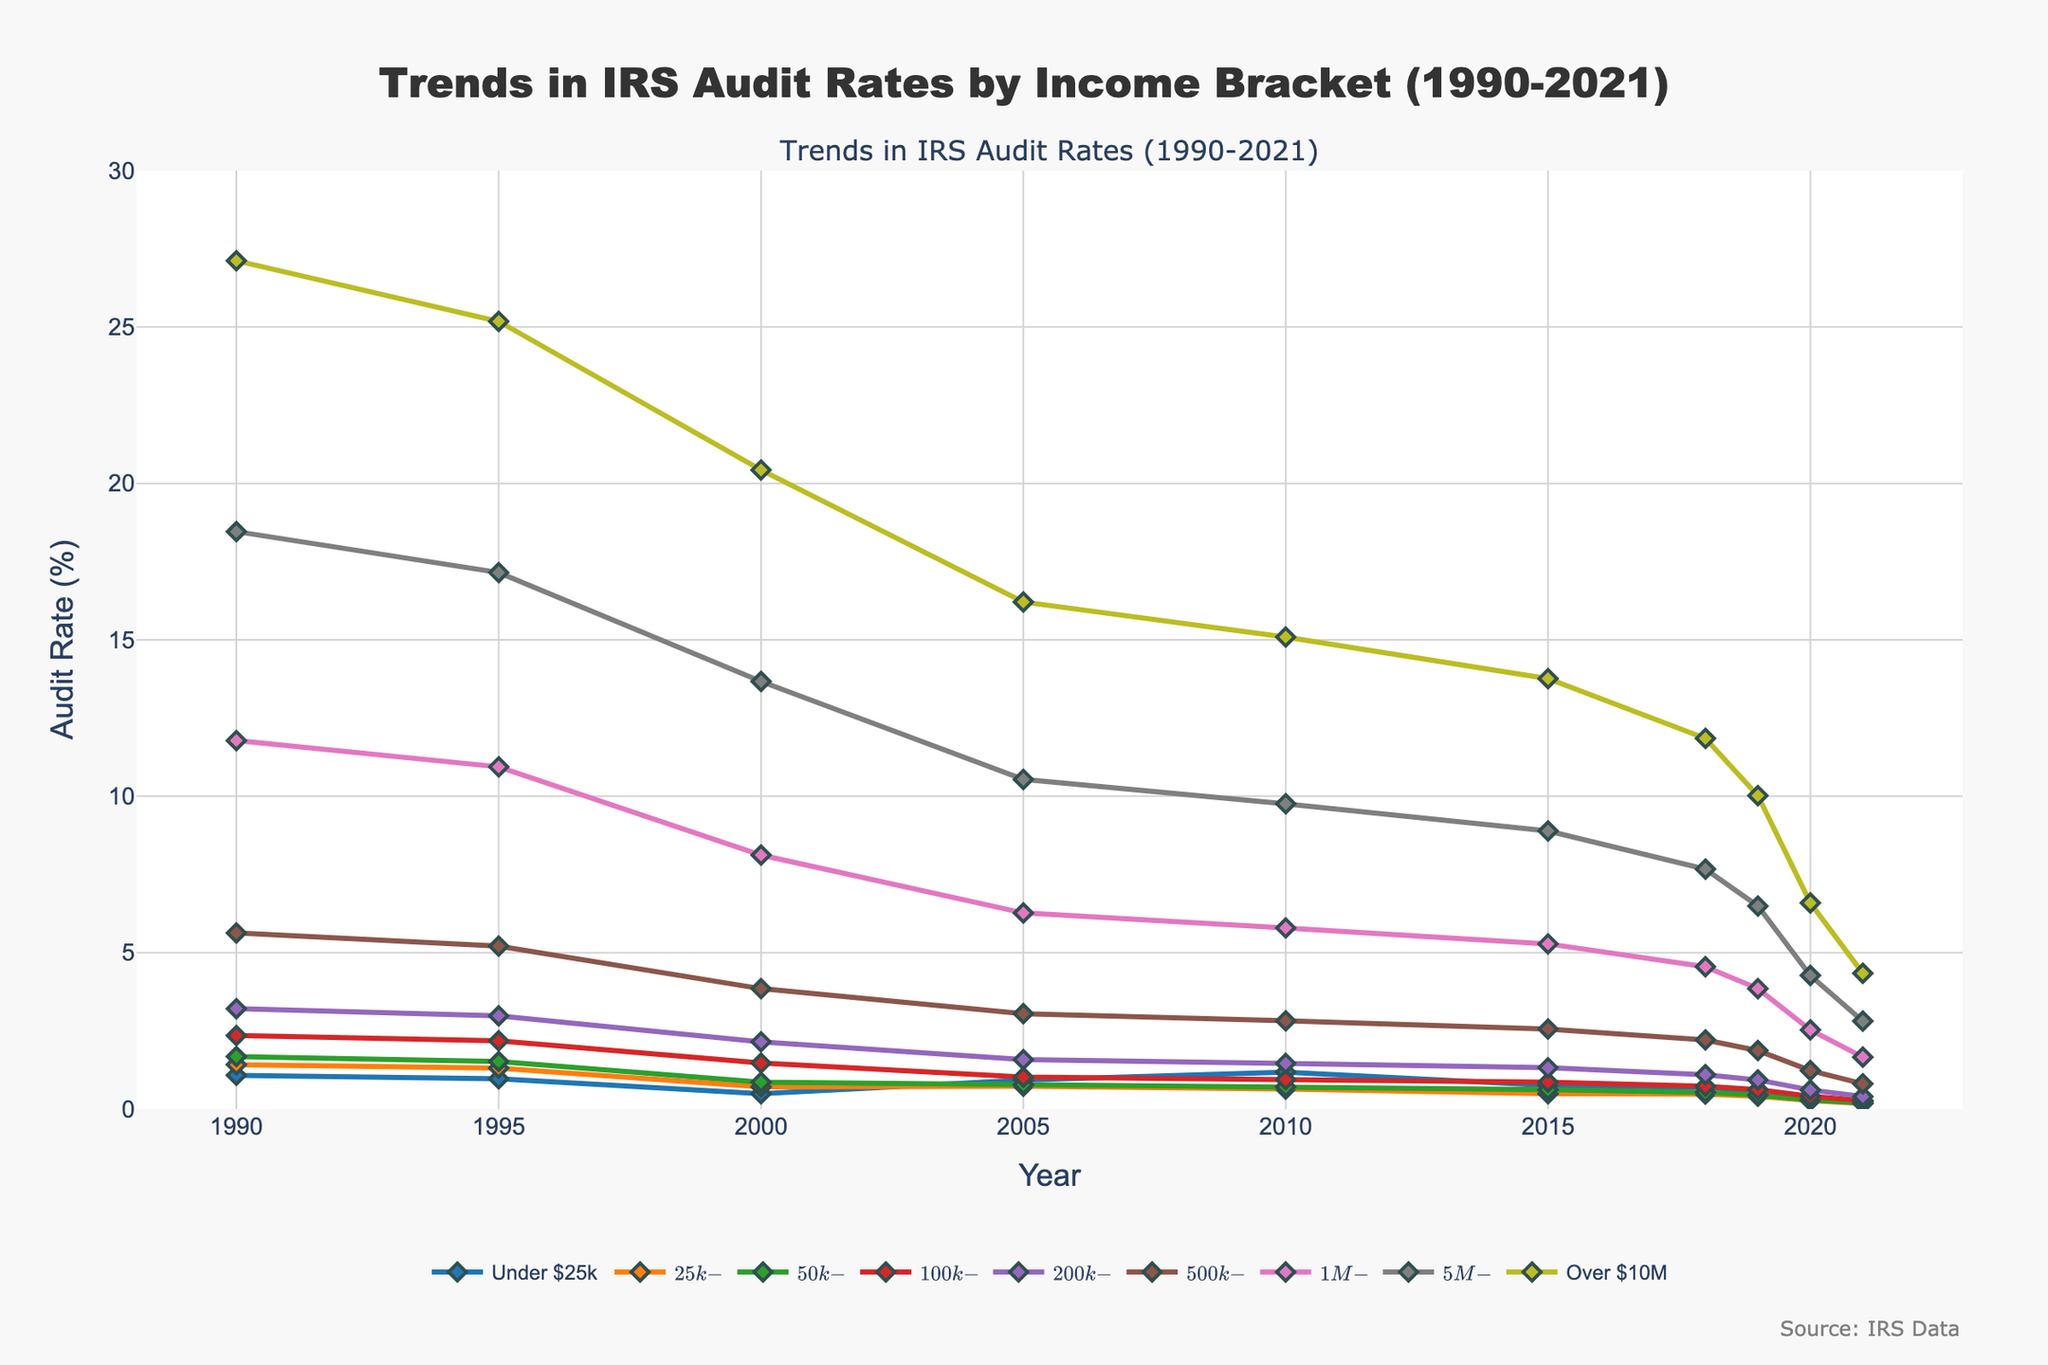What trend can you observe for audit rates for the income bracket "$25k-$50k" from 1990 to 2021? The audit rates for the $25k-$50k income bracket consistently decline from 1990 (1.42%) to 2021 (0.18%), indicating fewer audits over time.
Answer: Consistent decline Which income bracket had the highest audit rate in 2021? Observing the end of each line in 2021, the income bracket "Over $10M" had the highest audit rate in 2021.
Answer: Over $10M Compare the audit rates for the income brackets "Under $25k" and "$200k-$500k" in 2000. Which one was higher and by how much? In 2000, the audit rate for "Under $25k" was 0.49% and for "$200k-$500k" was 2.15%. The rate for "$200k-$500k" was higher by 2.15 - 0.49 = 1.66%.
Answer: $200k-$500k by 1.66% Identify the income bracket with the largest decrease in audit rate from 1995 to 2021. What is the difference in percentages? By comparing each bracket, "$5M-$10M" had the largest decrease from 17.15% in 1995 to 2.81% in 2021, which is a decrease of 17.15 - 2.81 = 14.34%.
Answer: $5M-$10M by 14.34% Which income brackets had audit rates below 1% in 2020? The income brackets "Under $25k", "$25k-$50k", "$50k-$100k", "$100k-$200k", and "$200k-$500k" had audit rates below 1% in 2020.
Answer: Under $25k, $25k-$50k, $50k-$100k, $100k-$200k, $200k-$500k What is the average audit rate for the income bracket "Over $10M" over the entire period shown? Sum the audit rates for "Over $10M" from 1990 to 2021 and divide by the number of years (9+1). (27.12 + 25.18 + 20.43 + 16.21 + 15.09 + 13.76 + 11.85 + 10.02 + 6.59 + 4.34) / 10 = 15.759%.
Answer: 15.76% In 1990, how much higher was the audit rate for the income bracket "$1M-$5M" compared to "$200k-$500k"? In 1990, the audit rate for "$1M-$5M" was 11.78% and for "$200k-$500k" was 3.21%. The difference is 11.78 - 3.21 = 8.57%.
Answer: 8.57% Which income bracket shows the most significant drop in audit rate between 2018 and 2021? What is the drop in percentage points? The income bracket "Over $10M" shows the most significant drop, from 11.85% in 2018 to 4.34% in 2021. The drop is 11.85 - 4.34 = 7.51%.
Answer: Over $10M by 7.51% How did the audit rate for the "$500k-$1M" income bracket change from 2010 to 2021? The audit rate for "$500k-$1M" decreased from 2.82% in 2010 to 0.81% in 2021.
Answer: Decreased 